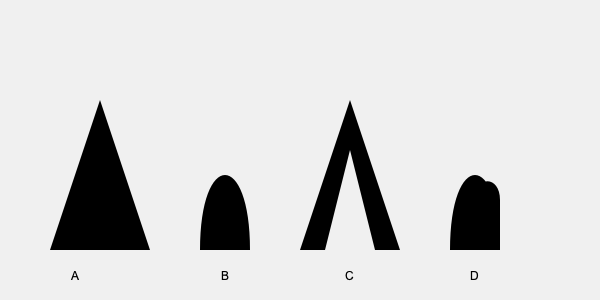Match the silhouettes A, B, C, and D to their corresponding superheroes: Batman, Spider-Man, Superman, and Wonder Woman. Which silhouette represents the iconic costume of Superman? To identify Superman's silhouette, let's analyze each shape:

1. Silhouette A: This triangular shape represents Batman's iconic pointed cowl and cape.

2. Silhouette B: This rounded shape with a curved top represents Spider-Man's mask and eye lenses.

3. Silhouette C: This silhouette shows a cape and a distinct "V" shape on the chest, which is characteristic of Superman's costume. The "V" represents the neckline of his suit and the beginning of his iconic "S" symbol.

4. Silhouette D: This shape features a tiara-like top and a curved lower half, representing Wonder Woman's tiara and her iconic costume design.

Based on these observations, we can conclude that Silhouette C represents Superman's iconic costume.
Answer: C 